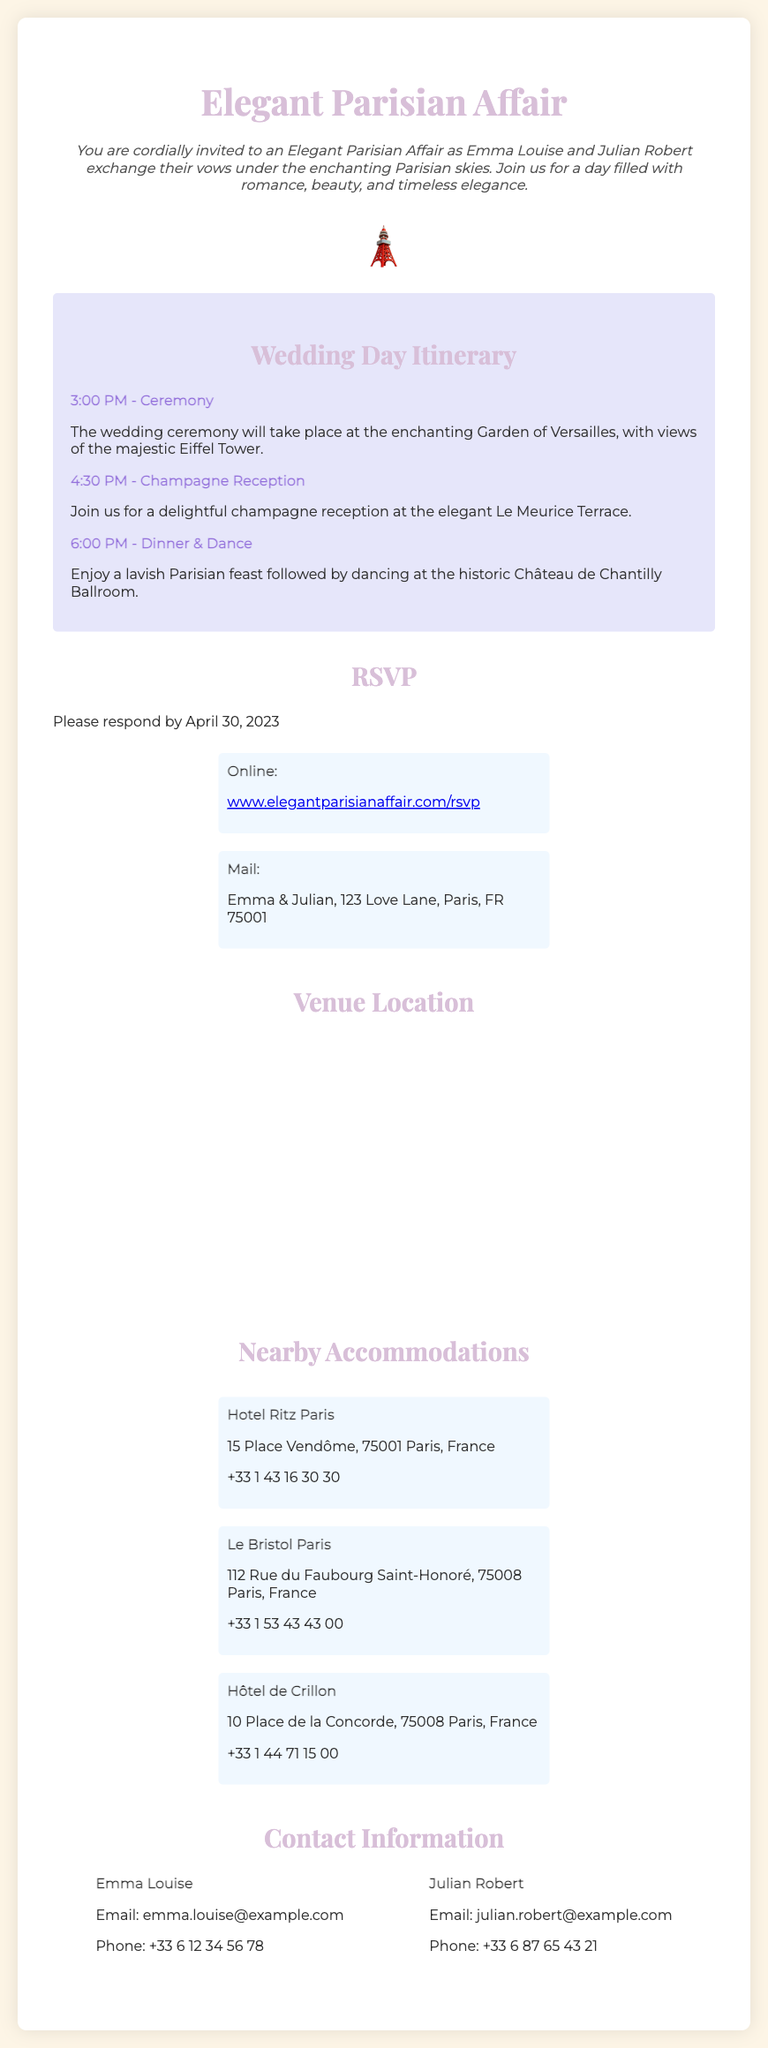What is the venue for the ceremony? The ceremony is held at the Garden of Versailles, as mentioned in the itinerary.
Answer: Garden of Versailles What time does the champagne reception start? The champagne reception time is specified in the itinerary as 4:30 PM.
Answer: 4:30 PM What is the RSVP deadline? The RSVP deadline is stated in the document as April 30, 2023.
Answer: April 30, 2023 How many accommodations are listed? There are three accommodations mentioned in the document.
Answer: Three Which email contact belongs to Julian Robert? The document specifies Julian Robert's email address for contact.
Answer: julian.robert@example.com What is the main theme of the wedding invitation? The overall theme of the wedding invitation reflects an Elegant Parisian aesthetic, as indicated in the title.
Answer: Elegant Parisian What type of event is being invited to? The event being invited to is a wedding ceremony.
Answer: Wedding What is the color scheme used in the invitation? The invitation describes the color scheme as soft pastel colors.
Answer: Soft pastel colors Where can guests respond to the RSVP online? The RSVP link is provided for guests to respond online in the document.
Answer: www.elegantparisianaffair.com/rsvp 